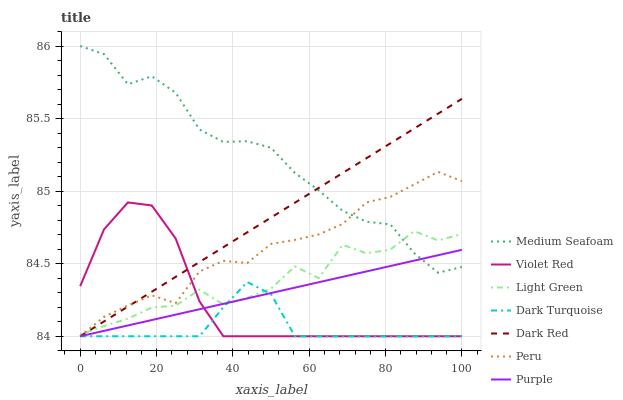Does Dark Turquoise have the minimum area under the curve?
Answer yes or no. Yes. Does Medium Seafoam have the maximum area under the curve?
Answer yes or no. Yes. Does Light Green have the minimum area under the curve?
Answer yes or no. No. Does Light Green have the maximum area under the curve?
Answer yes or no. No. Is Purple the smoothest?
Answer yes or no. Yes. Is Light Green the roughest?
Answer yes or no. Yes. Is Light Green the smoothest?
Answer yes or no. No. Is Purple the roughest?
Answer yes or no. No. Does Light Green have the lowest value?
Answer yes or no. No. Does Medium Seafoam have the highest value?
Answer yes or no. Yes. Does Light Green have the highest value?
Answer yes or no. No. Is Violet Red less than Medium Seafoam?
Answer yes or no. Yes. Is Medium Seafoam greater than Violet Red?
Answer yes or no. Yes. Does Dark Red intersect Purple?
Answer yes or no. Yes. Is Dark Red less than Purple?
Answer yes or no. No. Is Dark Red greater than Purple?
Answer yes or no. No. Does Violet Red intersect Medium Seafoam?
Answer yes or no. No. 